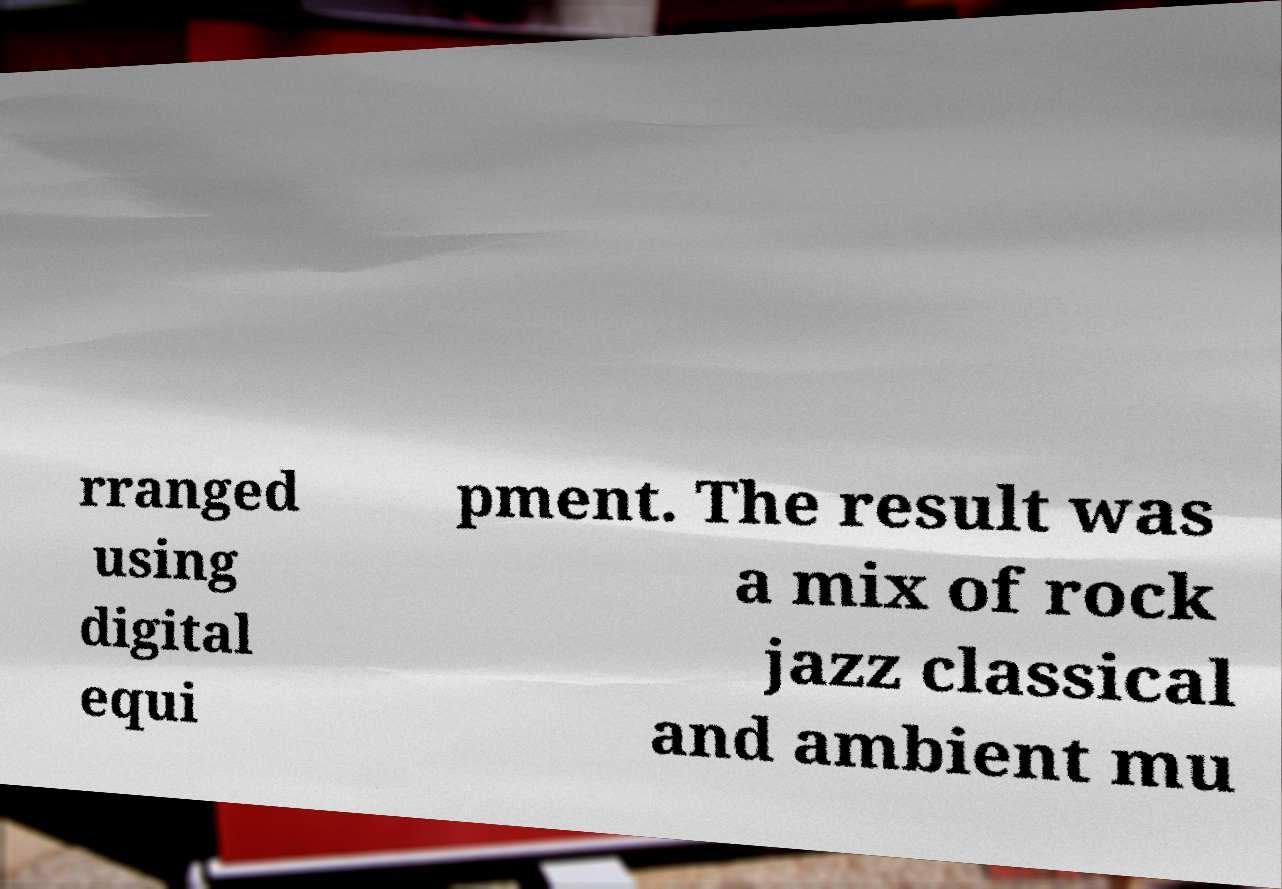Can you read and provide the text displayed in the image?This photo seems to have some interesting text. Can you extract and type it out for me? rranged using digital equi pment. The result was a mix of rock jazz classical and ambient mu 